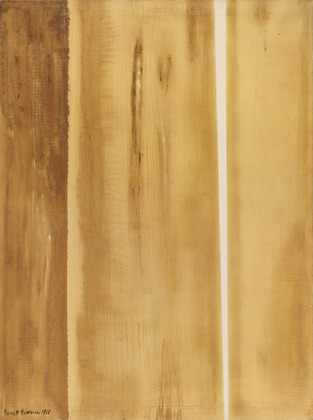Imagine you could walk into the painting, what would you see and feel? Entering the world of this painting, you’d be engulfed in a silent, earthy atmosphere. The vertical lines would tower above you like ancient pillars bathed in golden light. The air would be warm and filled with the scent of earth after a fresh rain, grounding your senses. The surface would feel rough under your touch, telling tales of erosion and time. You’d feel a profound sense of solitude and connection to nature, as if standing in a timeless realm where nature speaks directly to the soul. 